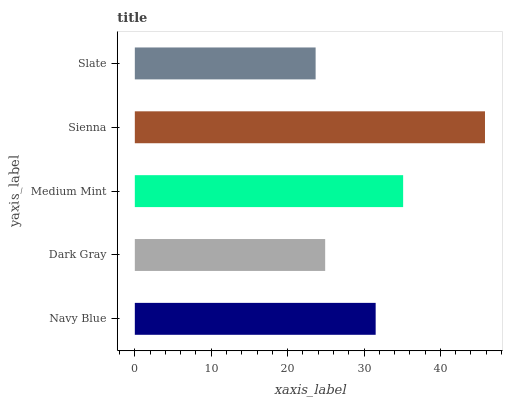Is Slate the minimum?
Answer yes or no. Yes. Is Sienna the maximum?
Answer yes or no. Yes. Is Dark Gray the minimum?
Answer yes or no. No. Is Dark Gray the maximum?
Answer yes or no. No. Is Navy Blue greater than Dark Gray?
Answer yes or no. Yes. Is Dark Gray less than Navy Blue?
Answer yes or no. Yes. Is Dark Gray greater than Navy Blue?
Answer yes or no. No. Is Navy Blue less than Dark Gray?
Answer yes or no. No. Is Navy Blue the high median?
Answer yes or no. Yes. Is Navy Blue the low median?
Answer yes or no. Yes. Is Dark Gray the high median?
Answer yes or no. No. Is Dark Gray the low median?
Answer yes or no. No. 